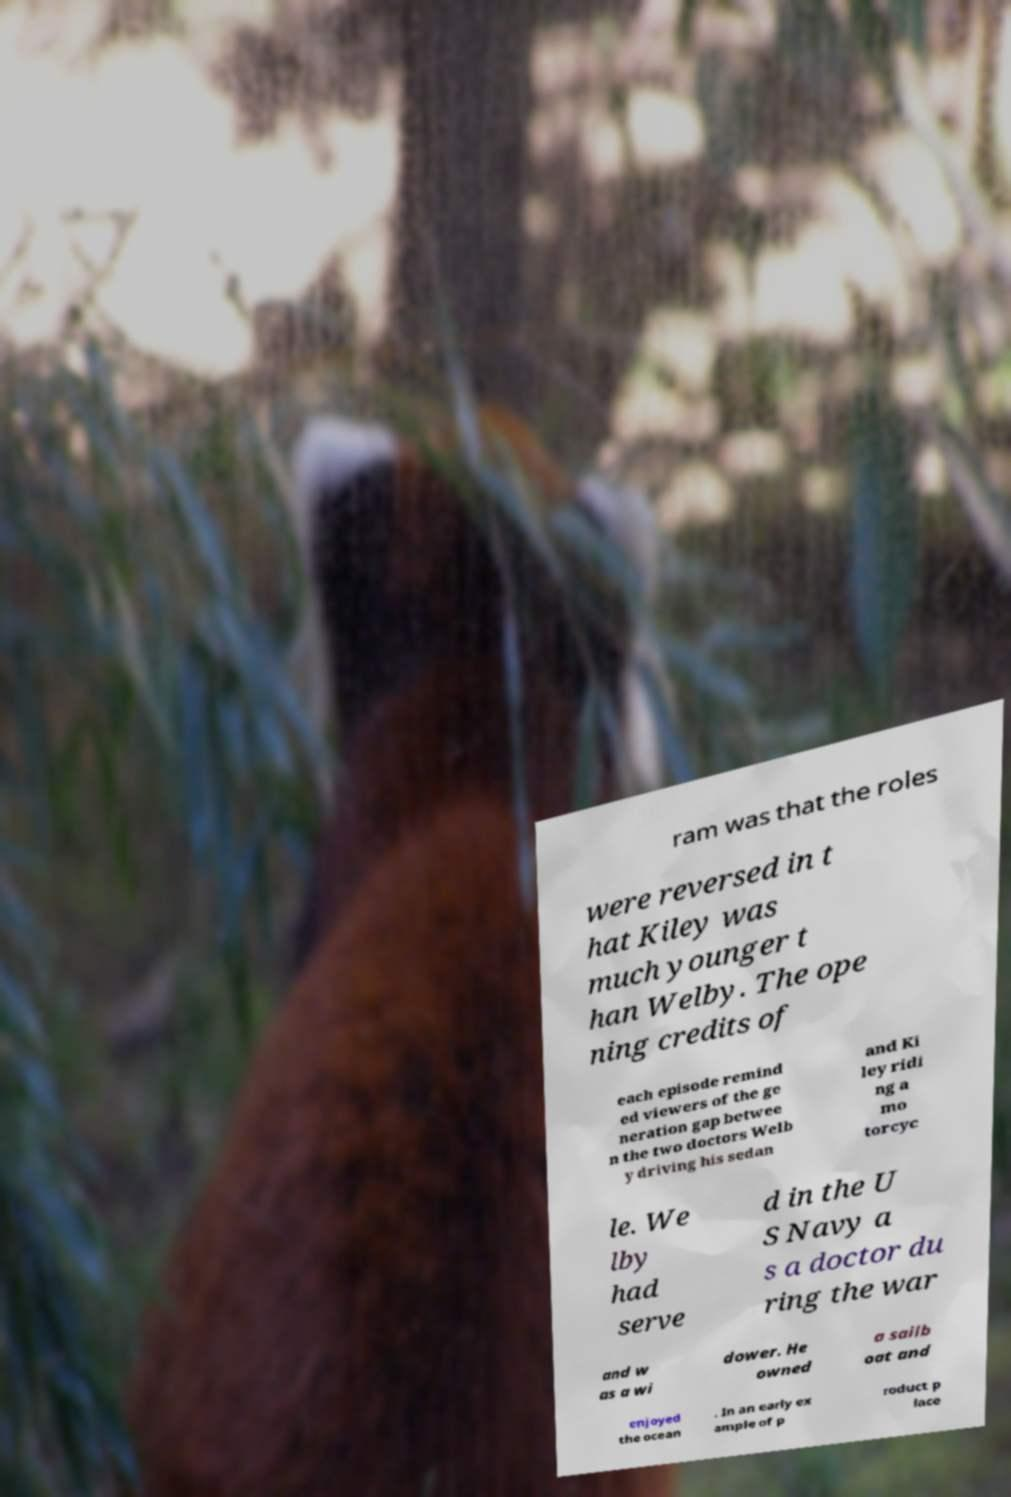Please read and relay the text visible in this image. What does it say? ram was that the roles were reversed in t hat Kiley was much younger t han Welby. The ope ning credits of each episode remind ed viewers of the ge neration gap betwee n the two doctors Welb y driving his sedan and Ki ley ridi ng a mo torcyc le. We lby had serve d in the U S Navy a s a doctor du ring the war and w as a wi dower. He owned a sailb oat and enjoyed the ocean . In an early ex ample of p roduct p lace 